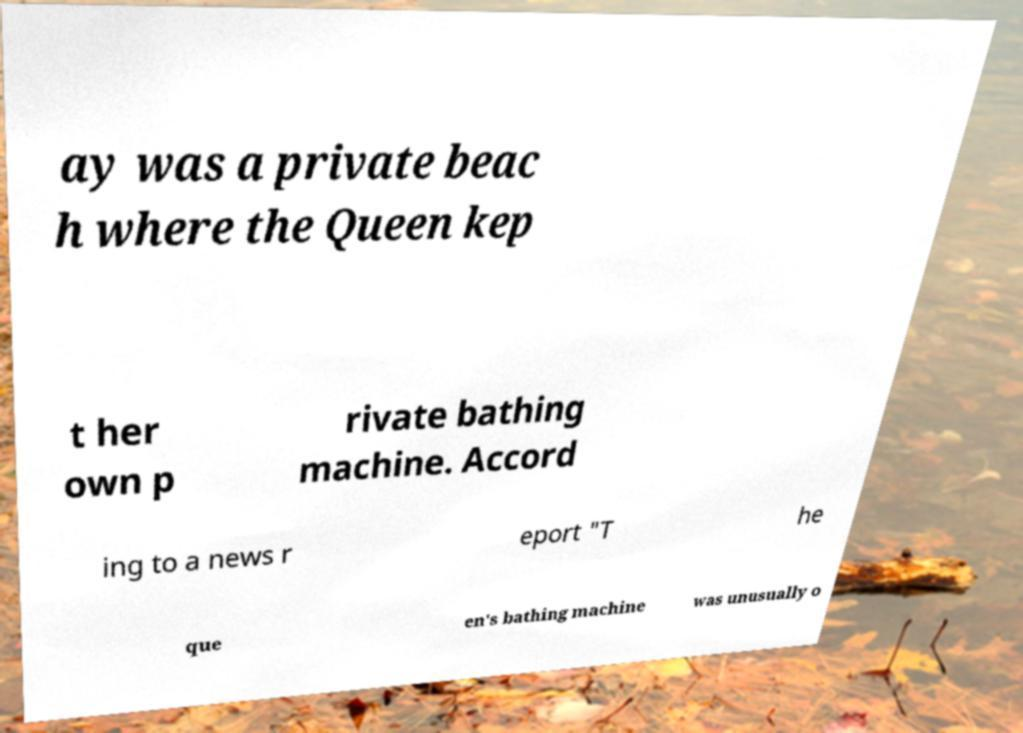Could you extract and type out the text from this image? ay was a private beac h where the Queen kep t her own p rivate bathing machine. Accord ing to a news r eport "T he que en's bathing machine was unusually o 